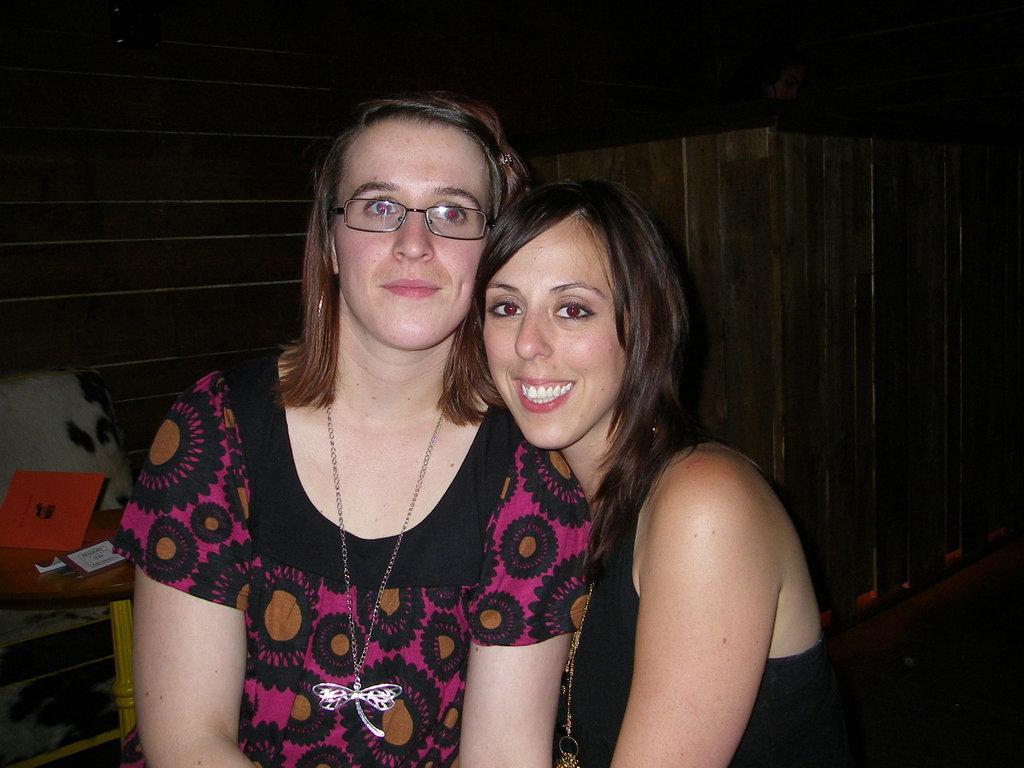Please provide a concise description of this image. This picture is inside view of a room. In the center of the image two ladies are present. On the left side of the image there is a table. On the table we can see books are there. In the background of the image we can see a wall. 